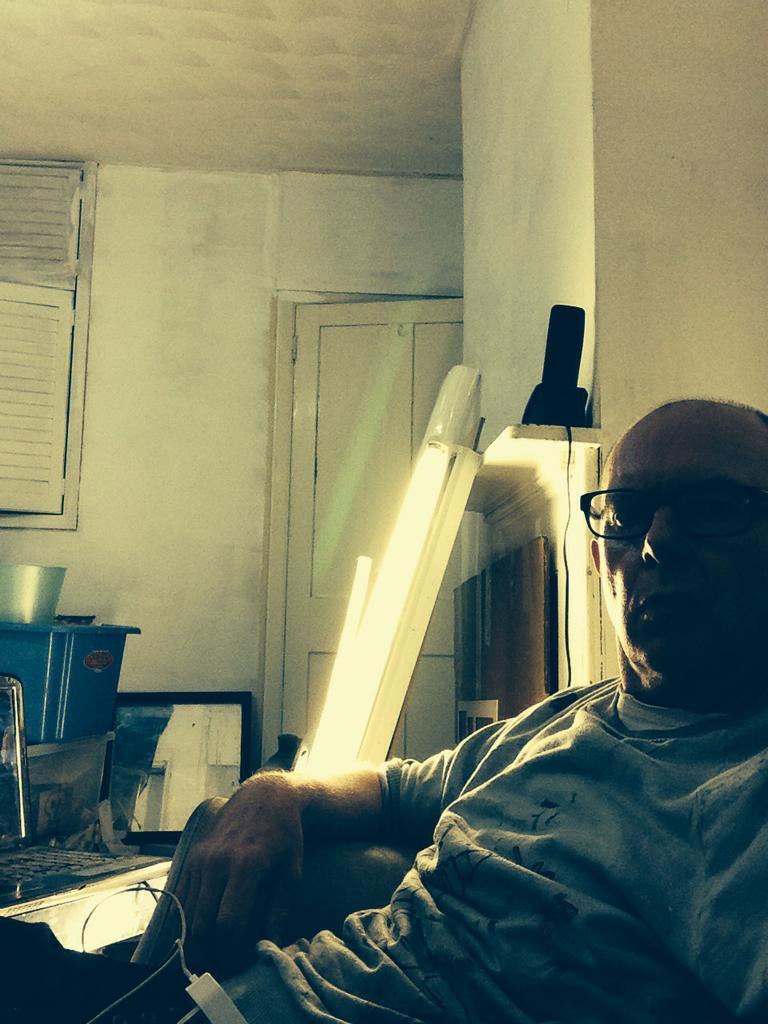Could you give a brief overview of what you see in this image? In the foreground of the picture there is a person. In the center of the picture there are lights. On the left there are boxes, window, wall and other objects. In the middle of the picture we can see a door. On the right it is well. 